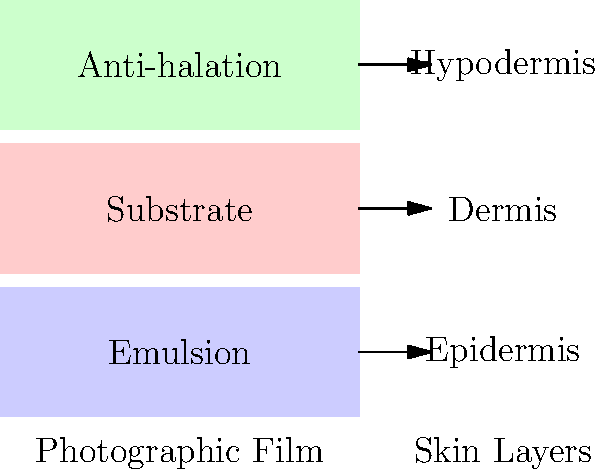In the context of biomechanics and photographic film structure, which layer of the skin most closely corresponds to the emulsion layer of a color photograph, and why? To answer this question, let's break down the layers of both photographic film and skin:

1. Photographic film layers (top to bottom):
   a) Emulsion layer: Contains light-sensitive chemicals
   b) Substrate layer: Provides support
   c) Anti-halation layer: Prevents light scattering

2. Skin layers (outer to inner):
   a) Epidermis: Outermost layer, contains melanin
   b) Dermis: Middle layer, provides support and contains blood vessels
   c) Hypodermis: Innermost layer, mainly composed of fat cells

3. Comparing the functions:
   - The emulsion layer in film is where the light-sensitive chemicals react to create the image.
   - In the skin, the epidermis contains melanin, which reacts to light and provides pigmentation.

4. Both the emulsion layer and the epidermis:
   - Are the outermost layers of their respective structures
   - Contain compounds that react to light (light-sensitive chemicals in film, melanin in skin)
   - Play a crucial role in capturing or responding to light

5. The substrate layer of film corresponds more closely to the dermis, as both provide structural support.

6. The anti-halation layer of film doesn't have a direct analog in skin layers, but the hypodermis serves a protective function similar to preventing light scattering.

Therefore, the epidermis most closely corresponds to the emulsion layer of a color photograph due to its light-reactive properties and position as the outermost layer.
Answer: Epidermis 